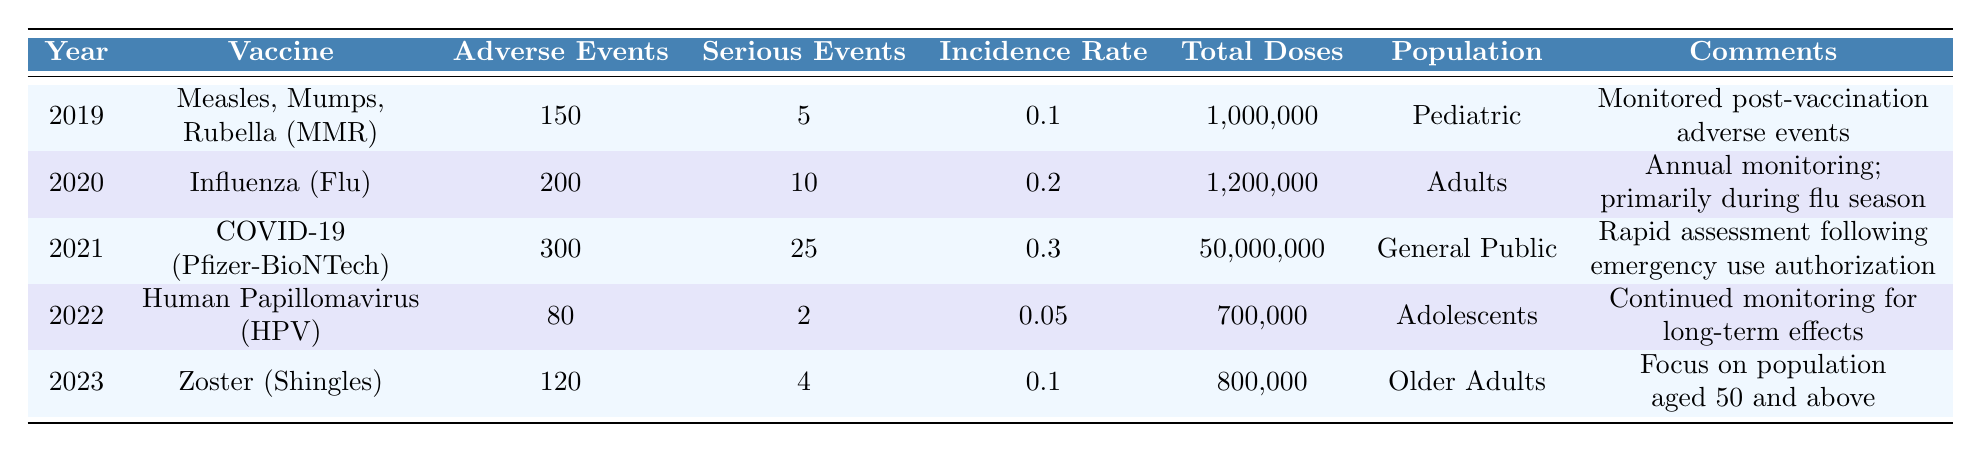What year had the highest number of reported adverse events? By examining the column for adverse events reported, we see that the highest value is 300, which corresponds to the year 2021.
Answer: 2021 What is the incidence rate for the Human Papillomavirus vaccine in 2022? Referring to the table, the incidence rate for the HPV vaccine in 2022 is listed as 0.05.
Answer: 0.05 How many serious adverse events were reported for the Influenza vaccine in 2020? Looking at the table, the number of serious adverse events reported for the Influenza vaccine in 2020 is 10.
Answer: 10 What is the total number of adverse events reported across all years? To find the total, we sum the adverse events across all years: 150 + 200 + 300 + 80 + 120 = 850.
Answer: 850 Is the incidence rate for the COVID-19 (Pfizer-BioNTech) vaccine higher than that for the Measles, Mumps, Rubella (MMR) vaccine? The incidence rate for COVID-19 is 0.3, while for MMR it is 0.1, so yes, COVID-19 has a higher incidence rate.
Answer: Yes What is the average number of total doses administered for vaccines over the years? To find the average, we first sum the total doses: 1,000,000 + 1,200,000 + 50,000,000 + 700,000 + 800,000 = 53,700,000, then divide by 5 (the number of data points): 53,700,000 / 5 = 10,740,000.
Answer: 10,740,000 In which year was the lowest number of serious adverse events reported? By reviewing the serious adverse events column, the lowest number reported is 2, corresponding to the year 2022.
Answer: 2022 Did the number of adverse events reported for the Zoster vaccine in 2023 exceed those for the HPV vaccine in 2022? The Zoster vaccine had 120 adverse events in 2023, whereas the HPV vaccine had 80 in 2022. Therefore, 120 > 80, meaning it did exceed.
Answer: Yes What percentage of adverse events were serious for the COVID-19 vaccine? The percentage is calculated as (serious adverse events / adverse events reported) * 100. For COVID-19, this is (25 / 300) * 100, which equals 8.33%.
Answer: 8.33% Identify the vaccine with the second highest incidence rate. Looking at the incidence rates, the highest is 0.3 for COVID-19, followed by 0.2 for Influenza; thus, the second highest incidence rate is for Influenza vaccine in 2020.
Answer: Influenza (Flu) 